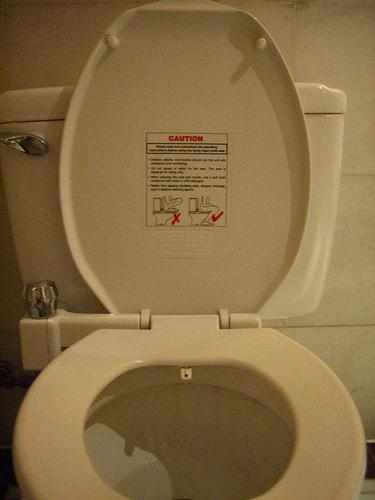Which object in the image is being referred to as "a small piece of metal sticking out on the toilet seat"? There is a chrome knob on the back right of the toilet seat. Describe the presence of any writing or stickers on the toilet. There is a sticker on the toilet lid with red writing. Identify the color and material of the toilet flush handle and its position in the image. The flush handle is metallic and chrome, it's on the back right of the toilet. In the context of the visual entailment task, give a possible hypothesis based on the given image. The toilet is in a clean and well-maintained bathroom. Answer the following multi-choice VQA question: What is the color of the hinge on the toilet seat? (A) Green (B) Black (C) White (D) Blue (C) White Create a tagline for a product advertisement task that highlights the cleanliness of the toilet in the image. "Experience ultimate hygiene with our pristine white ceramic toilet – your key to a spotless bathroom!" What is the general condition of the wall behind the toilet? Also, mention the color and material of the tile. The wall behind the toilet is white with some yellow stained white tiles and it's made of ceramic. Choose a phrase from the image that best describes the current state of the toilet seat and lid. The toilet seat is round and white, and the lid is up. Explain what can be seen inside the toilet bowl. There is water in the toilet bowl and a shadow on the inside. Mention a detail about the caution sign on the toilet. The caution sign on the toilet tells people not to stand on it. 